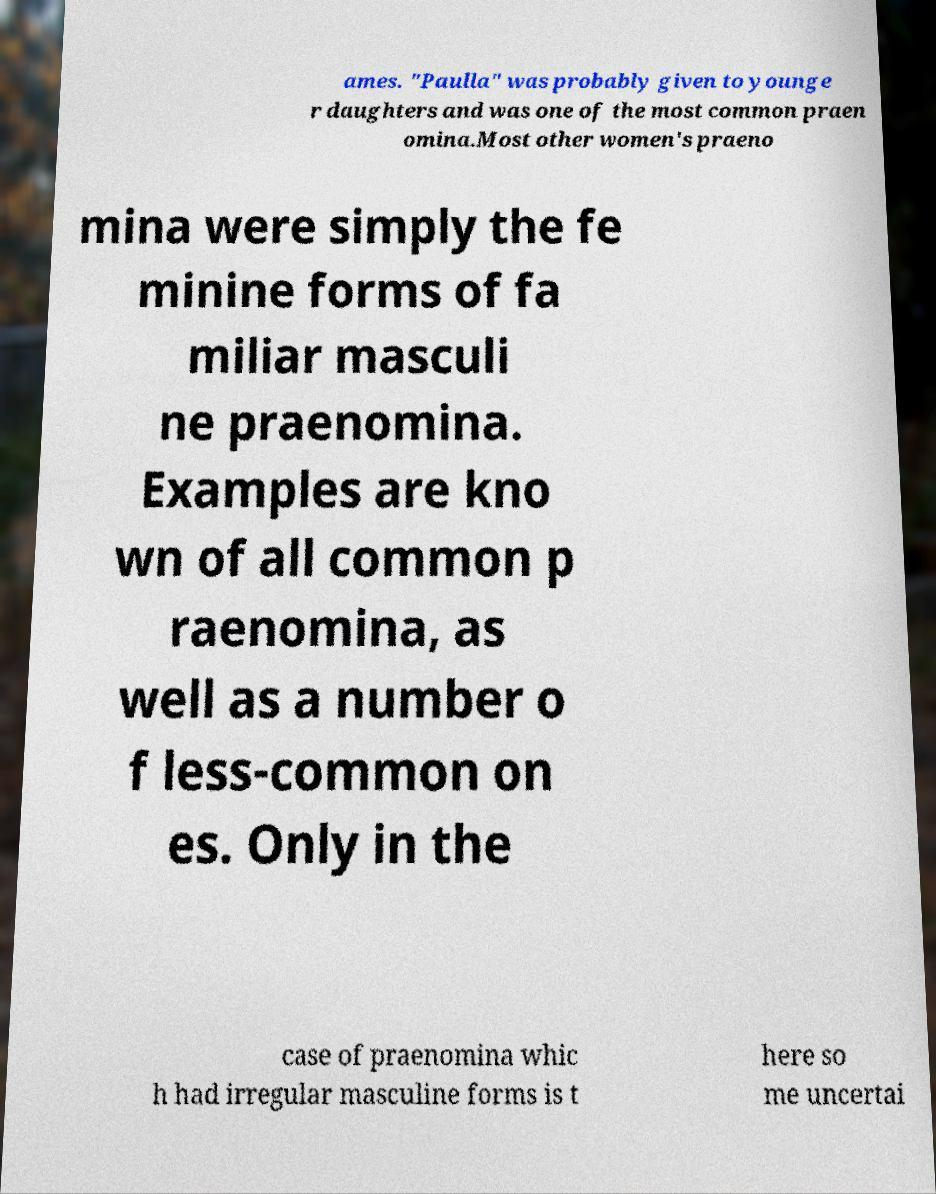Can you accurately transcribe the text from the provided image for me? ames. "Paulla" was probably given to younge r daughters and was one of the most common praen omina.Most other women's praeno mina were simply the fe minine forms of fa miliar masculi ne praenomina. Examples are kno wn of all common p raenomina, as well as a number o f less-common on es. Only in the case of praenomina whic h had irregular masculine forms is t here so me uncertai 